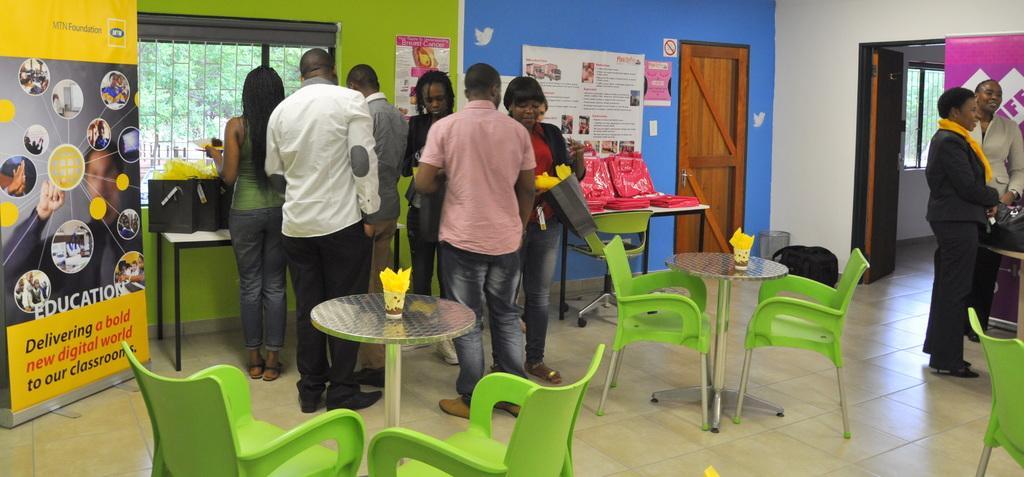How would you summarize this image in a sentence or two? There is a group of people. The people are standing one side of the room. On the right side we have two womens are standing other side table. The green color girl is holding like paper. There is a table and chairs. There is a books and glass on the table. We can see on the background there is a doors ,walls,and trees. There is a poster. The poster caption name is delivering book digital our classrooms. 